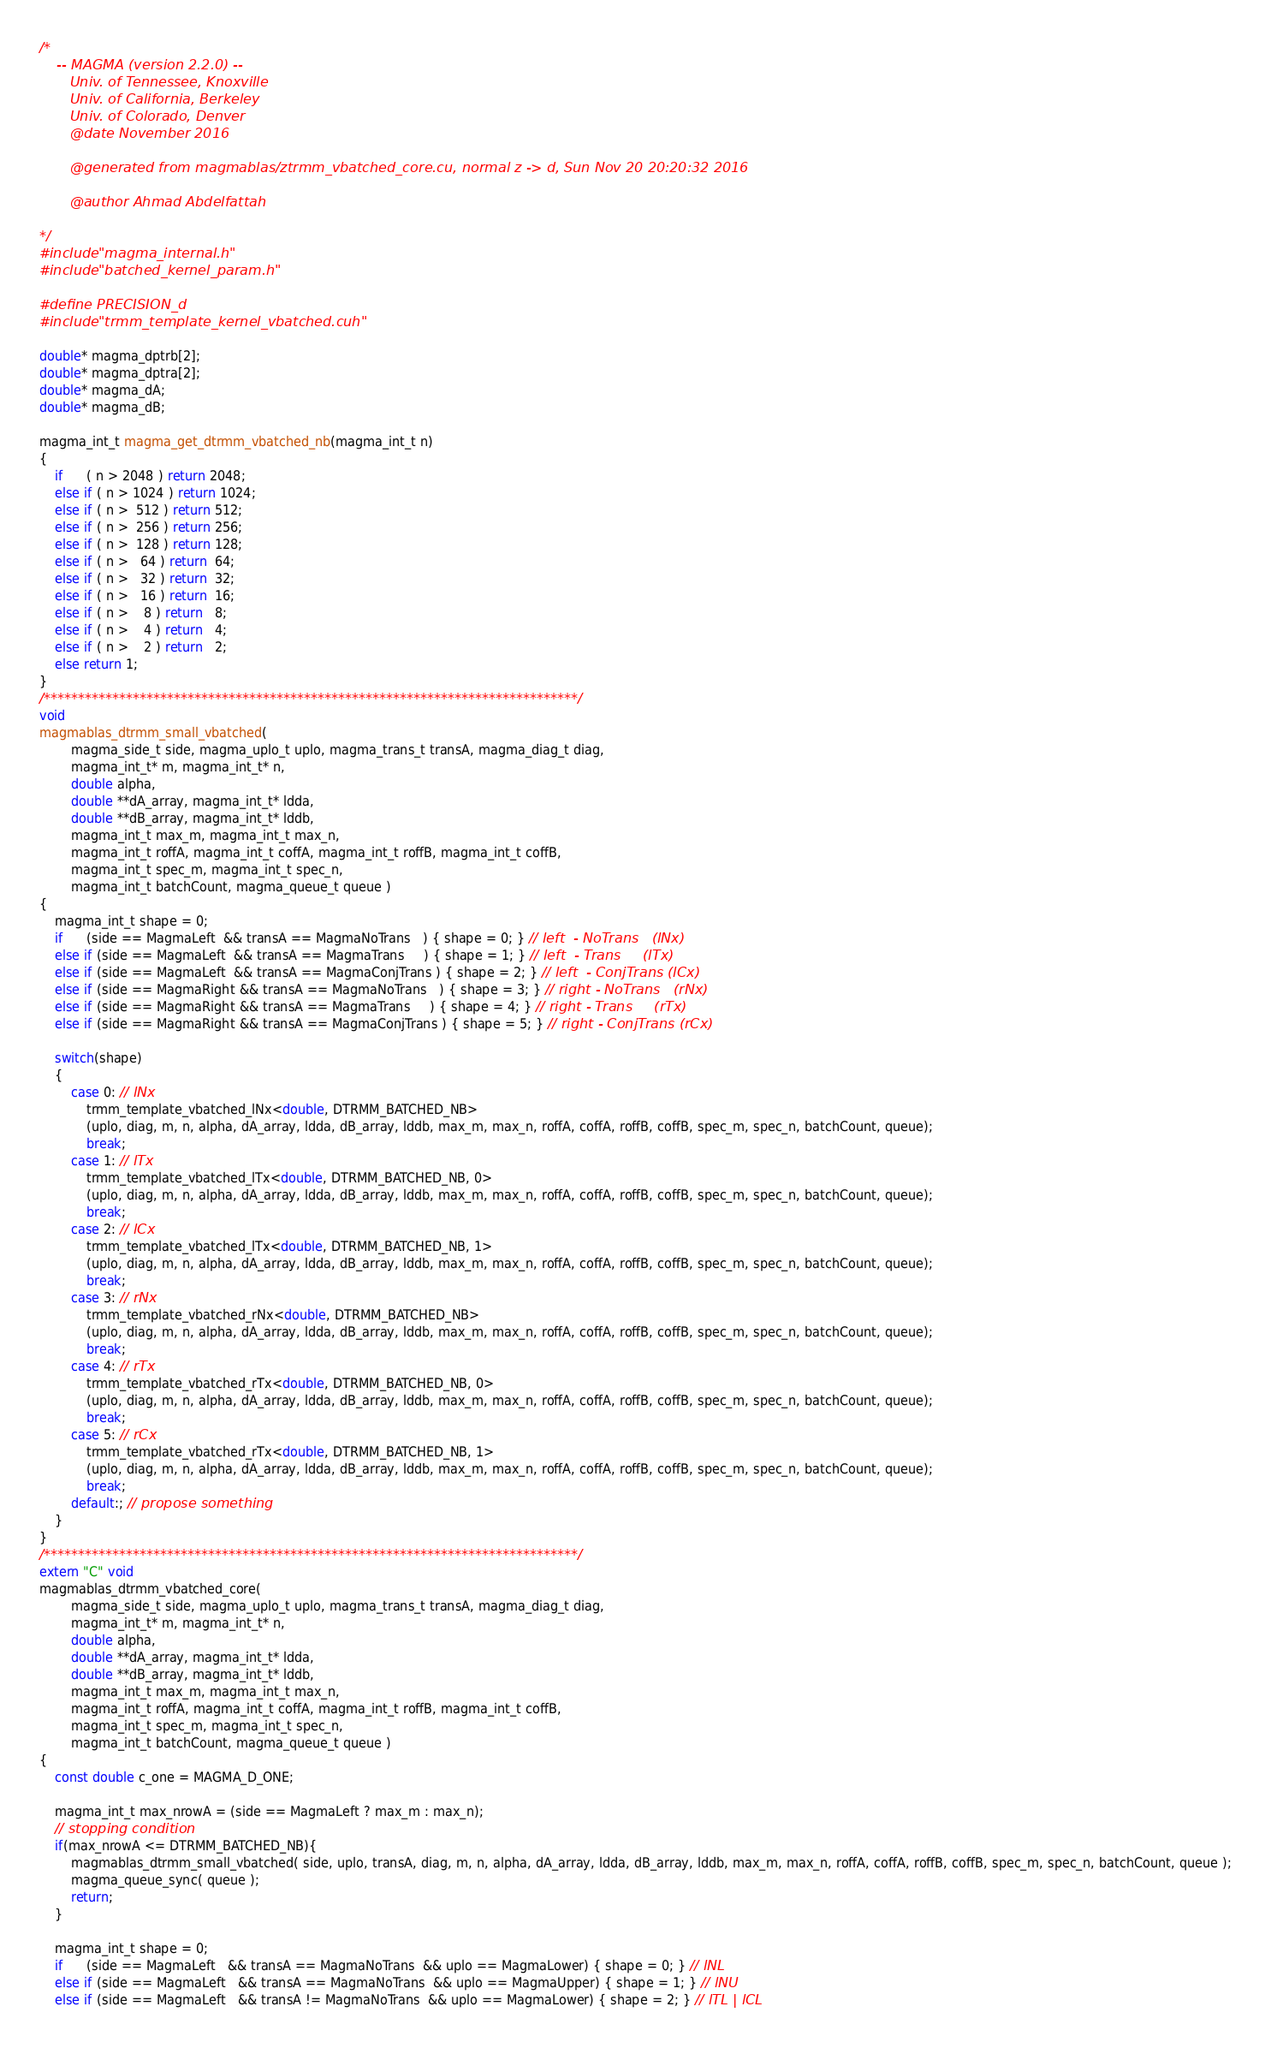Convert code to text. <code><loc_0><loc_0><loc_500><loc_500><_Cuda_>/*
    -- MAGMA (version 2.2.0) --
       Univ. of Tennessee, Knoxville
       Univ. of California, Berkeley
       Univ. of Colorado, Denver
       @date November 2016

       @generated from magmablas/ztrmm_vbatched_core.cu, normal z -> d, Sun Nov 20 20:20:32 2016

       @author Ahmad Abdelfattah
       
*/
#include "magma_internal.h"
#include "batched_kernel_param.h"

#define PRECISION_d
#include "trmm_template_kernel_vbatched.cuh"

double* magma_dptrb[2];
double* magma_dptra[2];
double* magma_dA;
double* magma_dB;

magma_int_t magma_get_dtrmm_vbatched_nb(magma_int_t n)
{
    if      ( n > 2048 ) return 2048;
    else if ( n > 1024 ) return 1024;
    else if ( n >  512 ) return 512;
    else if ( n >  256 ) return 256;
    else if ( n >  128 ) return 128;
    else if ( n >   64 ) return  64;
    else if ( n >   32 ) return  32;
    else if ( n >   16 ) return  16;
    else if ( n >    8 ) return   8;
    else if ( n >    4 ) return   4;
    else if ( n >    2 ) return   2;
    else return 1;
}
/******************************************************************************/
void
magmablas_dtrmm_small_vbatched(
        magma_side_t side, magma_uplo_t uplo, magma_trans_t transA, magma_diag_t diag, 
        magma_int_t* m, magma_int_t* n, 
        double alpha, 
        double **dA_array, magma_int_t* ldda,
        double **dB_array, magma_int_t* lddb, 
        magma_int_t max_m, magma_int_t max_n, 
        magma_int_t roffA, magma_int_t coffA, magma_int_t roffB, magma_int_t coffB, 
        magma_int_t spec_m, magma_int_t spec_n, 
        magma_int_t batchCount, magma_queue_t queue )
{
    magma_int_t shape = 0;
    if      (side == MagmaLeft  && transA == MagmaNoTrans   ) { shape = 0; } // left  - NoTrans   (lNx)
    else if (side == MagmaLeft  && transA == MagmaTrans     ) { shape = 1; } // left  - Trans     (lTx)
    else if (side == MagmaLeft  && transA == MagmaConjTrans ) { shape = 2; } // left  - ConjTrans (lCx)
    else if (side == MagmaRight && transA == MagmaNoTrans   ) { shape = 3; } // right - NoTrans   (rNx)
    else if (side == MagmaRight && transA == MagmaTrans     ) { shape = 4; } // right - Trans     (rTx)
    else if (side == MagmaRight && transA == MagmaConjTrans ) { shape = 5; } // right - ConjTrans (rCx)
    
    switch(shape)
    {
        case 0: // lNx
            trmm_template_vbatched_lNx<double, DTRMM_BATCHED_NB>
            (uplo, diag, m, n, alpha, dA_array, ldda, dB_array, lddb, max_m, max_n, roffA, coffA, roffB, coffB, spec_m, spec_n, batchCount, queue);
            break;
        case 1: // lTx
            trmm_template_vbatched_lTx<double, DTRMM_BATCHED_NB, 0>
            (uplo, diag, m, n, alpha, dA_array, ldda, dB_array, lddb, max_m, max_n, roffA, coffA, roffB, coffB, spec_m, spec_n, batchCount, queue);
            break;
        case 2: // lCx
            trmm_template_vbatched_lTx<double, DTRMM_BATCHED_NB, 1>
            (uplo, diag, m, n, alpha, dA_array, ldda, dB_array, lddb, max_m, max_n, roffA, coffA, roffB, coffB, spec_m, spec_n, batchCount, queue);
            break;
        case 3: // rNx
            trmm_template_vbatched_rNx<double, DTRMM_BATCHED_NB>
            (uplo, diag, m, n, alpha, dA_array, ldda, dB_array, lddb, max_m, max_n, roffA, coffA, roffB, coffB, spec_m, spec_n, batchCount, queue);
            break;
        case 4: // rTx
            trmm_template_vbatched_rTx<double, DTRMM_BATCHED_NB, 0>
            (uplo, diag, m, n, alpha, dA_array, ldda, dB_array, lddb, max_m, max_n, roffA, coffA, roffB, coffB, spec_m, spec_n, batchCount, queue);
            break;
        case 5: // rCx
            trmm_template_vbatched_rTx<double, DTRMM_BATCHED_NB, 1>
            (uplo, diag, m, n, alpha, dA_array, ldda, dB_array, lddb, max_m, max_n, roffA, coffA, roffB, coffB, spec_m, spec_n, batchCount, queue);
            break;
        default:; // propose something
    }
}
/******************************************************************************/
extern "C" void 
magmablas_dtrmm_vbatched_core(
        magma_side_t side, magma_uplo_t uplo, magma_trans_t transA, magma_diag_t diag, 
        magma_int_t* m, magma_int_t* n, 
        double alpha, 
        double **dA_array, magma_int_t* ldda,
        double **dB_array, magma_int_t* lddb, 
        magma_int_t max_m, magma_int_t max_n, 
        magma_int_t roffA, magma_int_t coffA, magma_int_t roffB, magma_int_t coffB, 
        magma_int_t spec_m, magma_int_t spec_n, 
        magma_int_t batchCount, magma_queue_t queue )
{
    const double c_one = MAGMA_D_ONE; 
    
    magma_int_t max_nrowA = (side == MagmaLeft ? max_m : max_n);
    // stopping condition
    if(max_nrowA <= DTRMM_BATCHED_NB){
        magmablas_dtrmm_small_vbatched( side, uplo, transA, diag, m, n, alpha, dA_array, ldda, dB_array, lddb, max_m, max_n, roffA, coffA, roffB, coffB, spec_m, spec_n, batchCount, queue );
        magma_queue_sync( queue );
        return;
    }
    
    magma_int_t shape = 0;
    if      (side == MagmaLeft   && transA == MagmaNoTrans  && uplo == MagmaLower) { shape = 0; } // lNL
    else if (side == MagmaLeft   && transA == MagmaNoTrans  && uplo == MagmaUpper) { shape = 1; } // lNU
    else if (side == MagmaLeft   && transA != MagmaNoTrans  && uplo == MagmaLower) { shape = 2; } // lTL | lCL</code> 